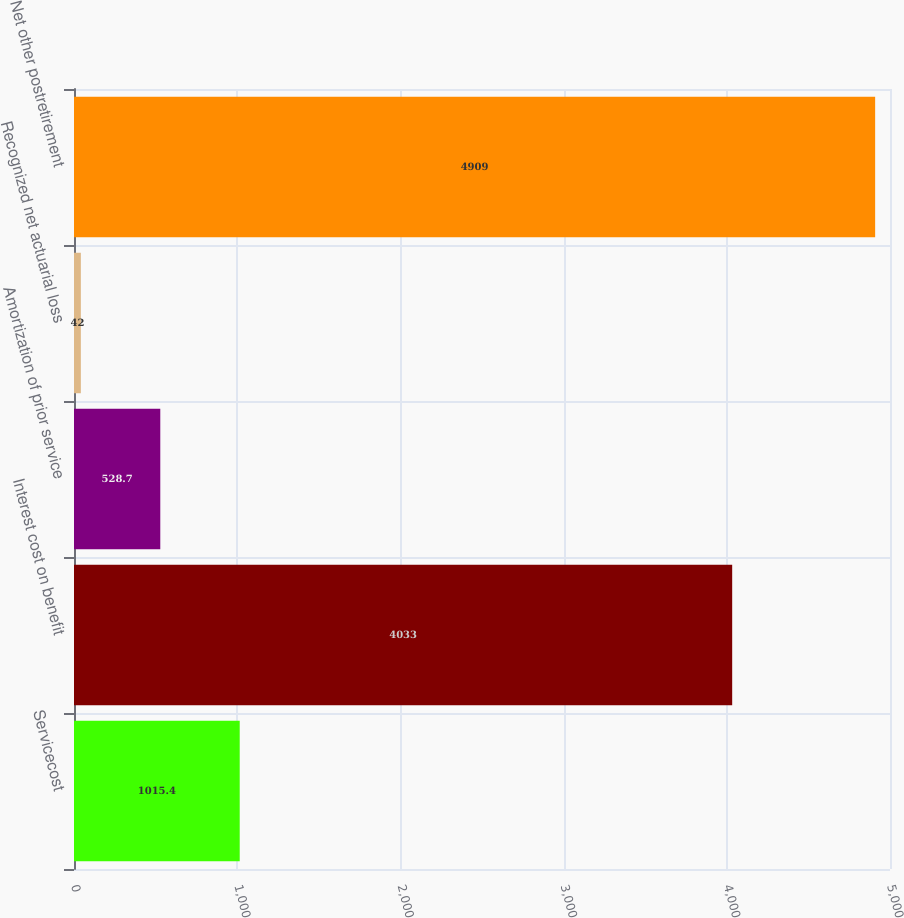<chart> <loc_0><loc_0><loc_500><loc_500><bar_chart><fcel>Servicecost<fcel>Interest cost on benefit<fcel>Amortization of prior service<fcel>Recognized net actuarial loss<fcel>Net other postretirement<nl><fcel>1015.4<fcel>4033<fcel>528.7<fcel>42<fcel>4909<nl></chart> 